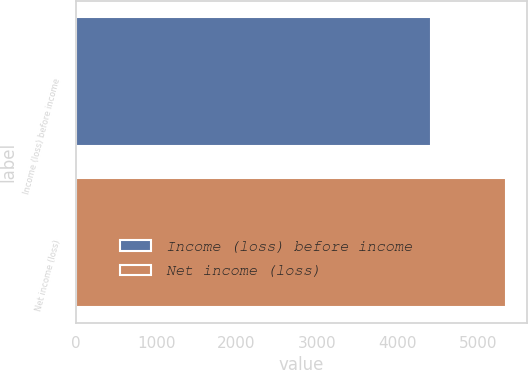Convert chart. <chart><loc_0><loc_0><loc_500><loc_500><bar_chart><fcel>Income (loss) before income<fcel>Net income (loss)<nl><fcel>4416<fcel>5346<nl></chart> 